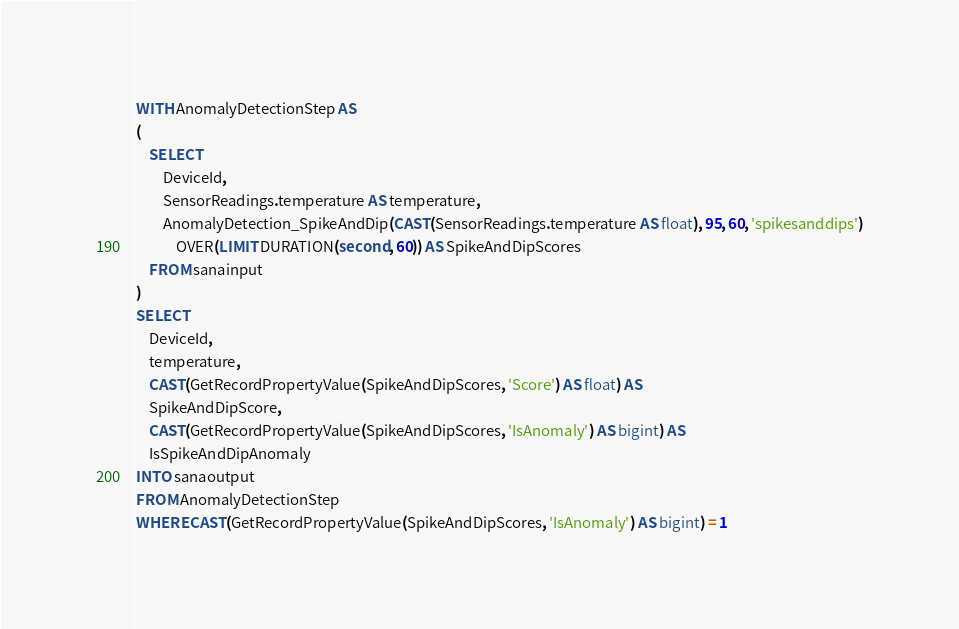Convert code to text. <code><loc_0><loc_0><loc_500><loc_500><_SQL_>WITH AnomalyDetectionStep AS
(
    SELECT
        DeviceId,
        SensorReadings.temperature AS temperature,
        AnomalyDetection_SpikeAndDip(CAST(SensorReadings.temperature AS float), 95, 60, 'spikesanddips')
            OVER(LIMIT DURATION(second, 60)) AS SpikeAndDipScores
    FROM sanainput
)
SELECT
    DeviceId,
    temperature,
    CAST(GetRecordPropertyValue(SpikeAndDipScores, 'Score') AS float) AS
    SpikeAndDipScore,
    CAST(GetRecordPropertyValue(SpikeAndDipScores, 'IsAnomaly') AS bigint) AS
    IsSpikeAndDipAnomaly
INTO sanaoutput
FROM AnomalyDetectionStep
WHERE CAST(GetRecordPropertyValue(SpikeAndDipScores, 'IsAnomaly') AS bigint) = 1</code> 